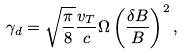<formula> <loc_0><loc_0><loc_500><loc_500>\gamma _ { d } = \sqrt { \frac { \pi } { 8 } } \frac { v _ { T } } { c } \Omega \left ( \frac { \delta B } { B } \right ) ^ { 2 } ,</formula> 